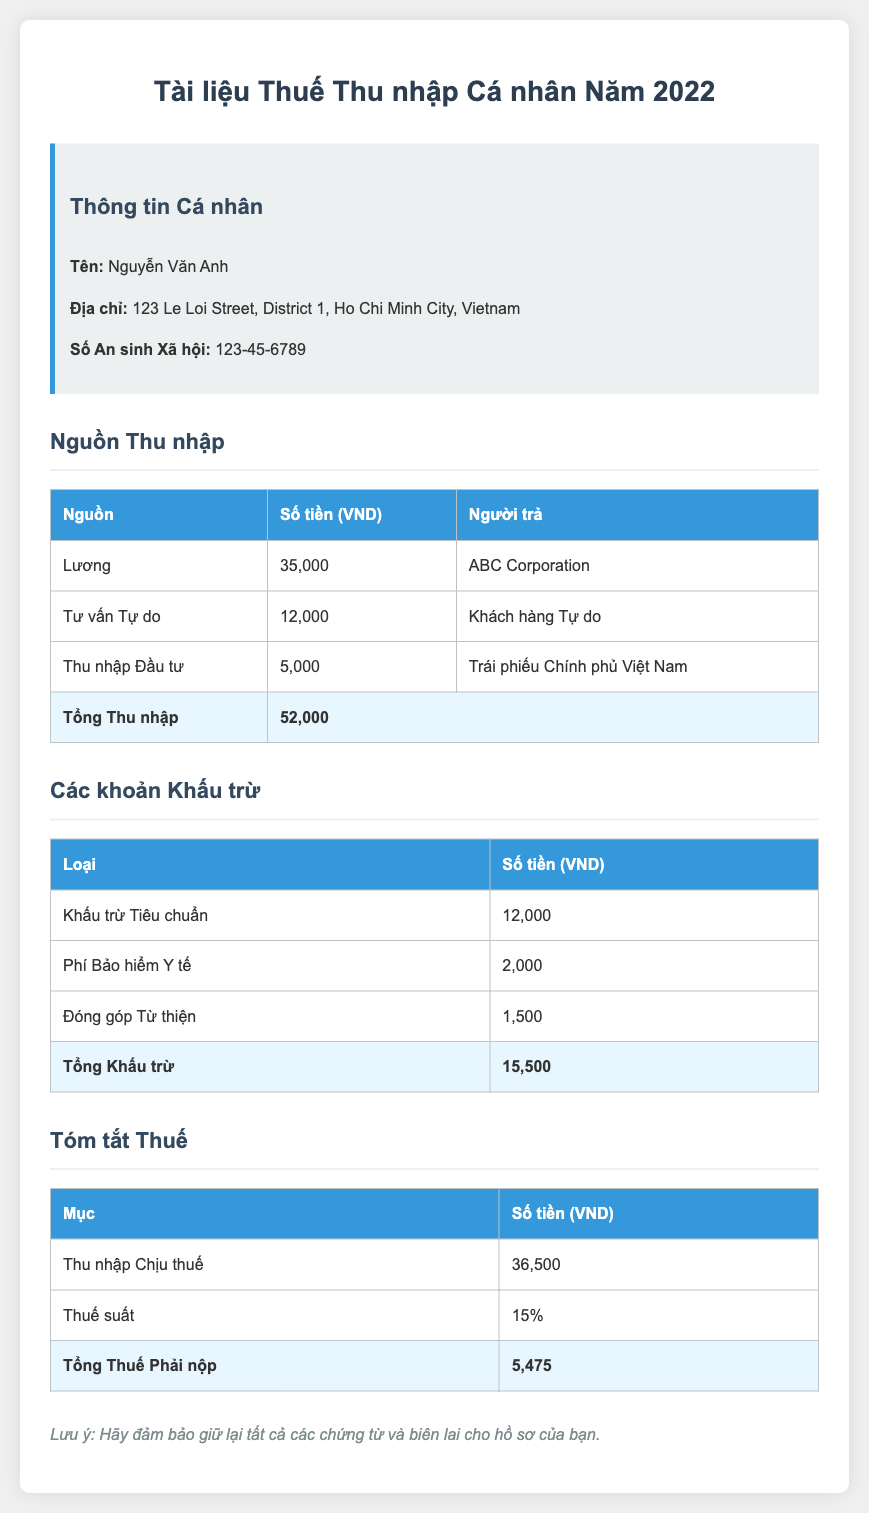What is the total income? The total income is listed at the bottom of the income sources table, which adds up all the individual income amounts.
Answer: 52,000 Who is the taxpayer? The taxpayer's name is provided at the top of the document in personal information.
Answer: Nguyễn Văn Anh What is the total tax payable? The total tax payable is mentioned in the tax summary section as the final amount after calculations.
Answer: 5,475 What is the self-employment income? The self-employment income is detailed in the income sources section and includes the amount earned from freelance consulting.
Answer: 12,000 What is the tax rate applied? The tax rate is stated in the tax summary section as the percentage used to calculate the total tax owed.
Answer: 15% What is the total deduction amount? The total deduction amount is the sum of all deductions listed in the deductions table, which reduces taxable income.
Answer: 15,500 What is the address of the taxpayer? The taxpayer's address is provided in the personal information section of the document.
Answer: 123 Le Loi Street, District 1, Ho Chi Minh City, Vietnam What is the amount from government bonds? The income from government bonds is specified in the income sources table.
Answer: 5,000 What is the standard deduction? The standard deduction amount is outlined in the deductions section of the document.
Answer: 12,000 